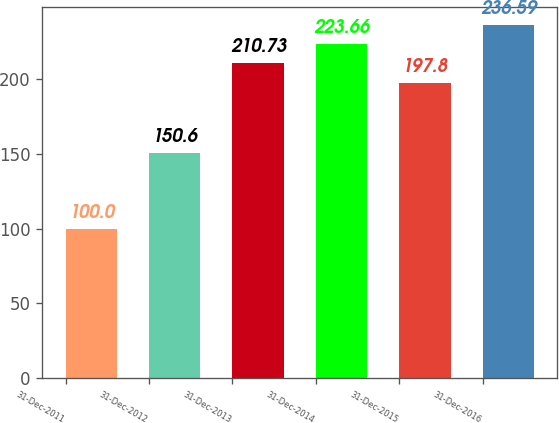Convert chart to OTSL. <chart><loc_0><loc_0><loc_500><loc_500><bar_chart><fcel>31-Dec-2011<fcel>31-Dec-2012<fcel>31-Dec-2013<fcel>31-Dec-2014<fcel>31-Dec-2015<fcel>31-Dec-2016<nl><fcel>100<fcel>150.6<fcel>210.73<fcel>223.66<fcel>197.8<fcel>236.59<nl></chart> 